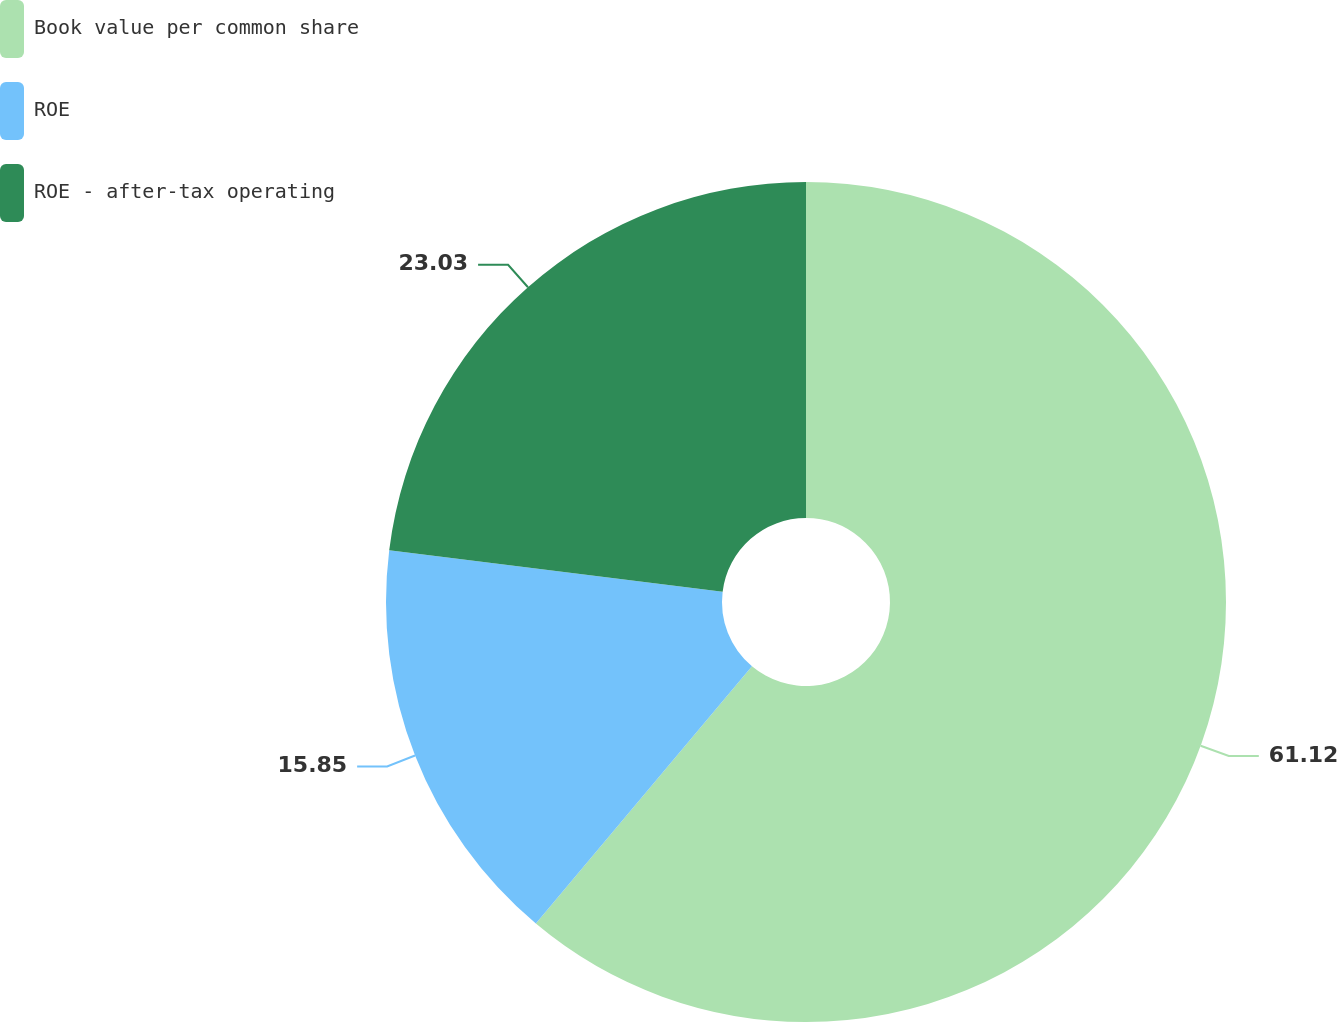<chart> <loc_0><loc_0><loc_500><loc_500><pie_chart><fcel>Book value per common share<fcel>ROE<fcel>ROE - after-tax operating<nl><fcel>61.12%<fcel>15.85%<fcel>23.03%<nl></chart> 